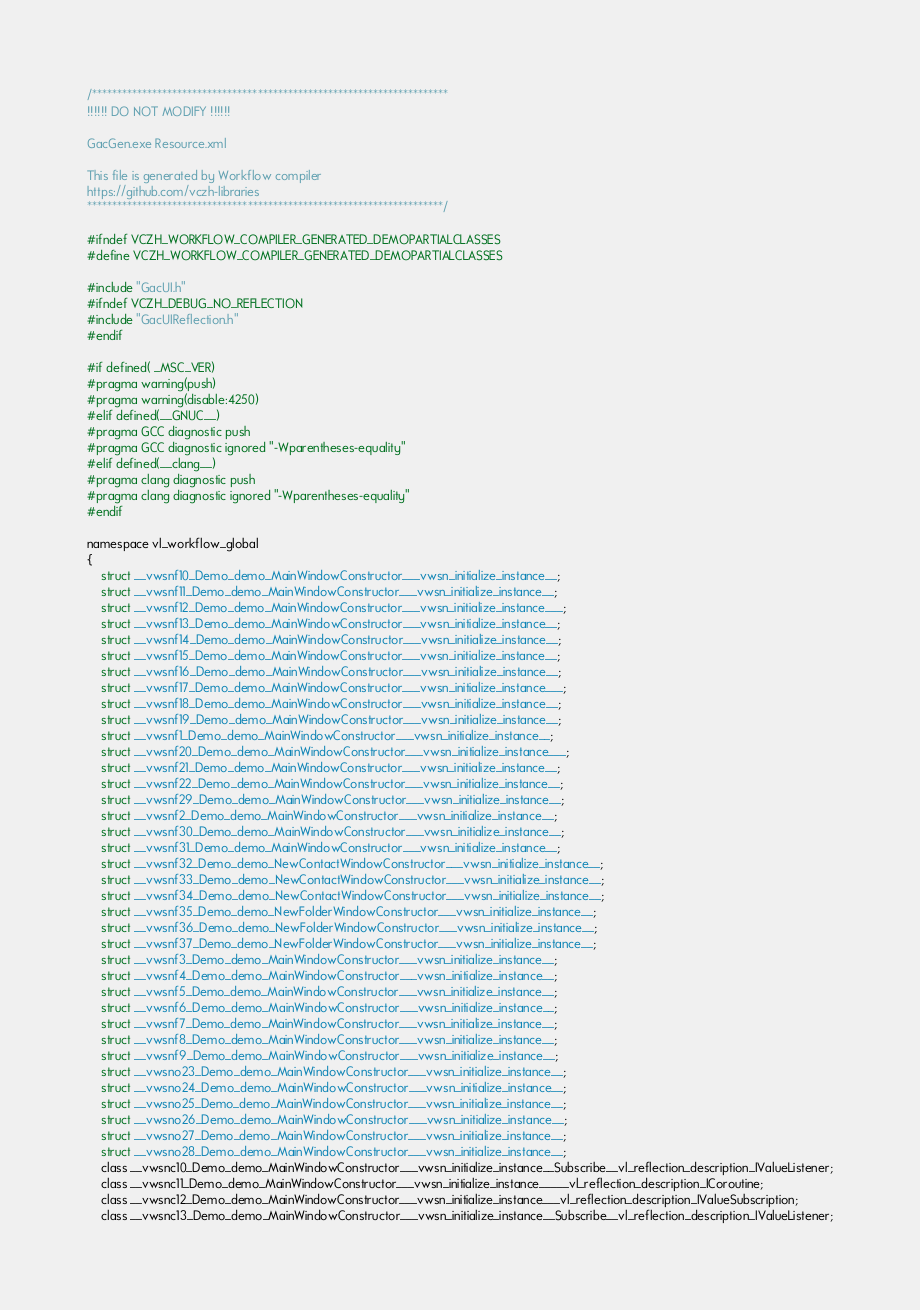Convert code to text. <code><loc_0><loc_0><loc_500><loc_500><_C_>/***********************************************************************
!!!!!! DO NOT MODIFY !!!!!!

GacGen.exe Resource.xml

This file is generated by Workflow compiler
https://github.com/vczh-libraries
***********************************************************************/

#ifndef VCZH_WORKFLOW_COMPILER_GENERATED_DEMOPARTIALCLASSES
#define VCZH_WORKFLOW_COMPILER_GENERATED_DEMOPARTIALCLASSES

#include "GacUI.h"
#ifndef VCZH_DEBUG_NO_REFLECTION
#include "GacUIReflection.h"
#endif

#if defined( _MSC_VER)
#pragma warning(push)
#pragma warning(disable:4250)
#elif defined(__GNUC__)
#pragma GCC diagnostic push
#pragma GCC diagnostic ignored "-Wparentheses-equality"
#elif defined(__clang__)
#pragma clang diagnostic push
#pragma clang diagnostic ignored "-Wparentheses-equality"
#endif

namespace vl_workflow_global
{
	struct __vwsnf10_Demo_demo_MainWindowConstructor___vwsn_initialize_instance__;
	struct __vwsnf11_Demo_demo_MainWindowConstructor___vwsn_initialize_instance__;
	struct __vwsnf12_Demo_demo_MainWindowConstructor___vwsn_initialize_instance___;
	struct __vwsnf13_Demo_demo_MainWindowConstructor___vwsn_initialize_instance__;
	struct __vwsnf14_Demo_demo_MainWindowConstructor___vwsn_initialize_instance__;
	struct __vwsnf15_Demo_demo_MainWindowConstructor___vwsn_initialize_instance__;
	struct __vwsnf16_Demo_demo_MainWindowConstructor___vwsn_initialize_instance__;
	struct __vwsnf17_Demo_demo_MainWindowConstructor___vwsn_initialize_instance___;
	struct __vwsnf18_Demo_demo_MainWindowConstructor___vwsn_initialize_instance__;
	struct __vwsnf19_Demo_demo_MainWindowConstructor___vwsn_initialize_instance__;
	struct __vwsnf1_Demo_demo_MainWindowConstructor___vwsn_initialize_instance__;
	struct __vwsnf20_Demo_demo_MainWindowConstructor___vwsn_initialize_instance___;
	struct __vwsnf21_Demo_demo_MainWindowConstructor___vwsn_initialize_instance__;
	struct __vwsnf22_Demo_demo_MainWindowConstructor___vwsn_initialize_instance__;
	struct __vwsnf29_Demo_demo_MainWindowConstructor___vwsn_initialize_instance__;
	struct __vwsnf2_Demo_demo_MainWindowConstructor___vwsn_initialize_instance__;
	struct __vwsnf30_Demo_demo_MainWindowConstructor___vwsn_initialize_instance__;
	struct __vwsnf31_Demo_demo_MainWindowConstructor___vwsn_initialize_instance__;
	struct __vwsnf32_Demo_demo_NewContactWindowConstructor___vwsn_initialize_instance__;
	struct __vwsnf33_Demo_demo_NewContactWindowConstructor___vwsn_initialize_instance__;
	struct __vwsnf34_Demo_demo_NewContactWindowConstructor___vwsn_initialize_instance__;
	struct __vwsnf35_Demo_demo_NewFolderWindowConstructor___vwsn_initialize_instance__;
	struct __vwsnf36_Demo_demo_NewFolderWindowConstructor___vwsn_initialize_instance__;
	struct __vwsnf37_Demo_demo_NewFolderWindowConstructor___vwsn_initialize_instance__;
	struct __vwsnf3_Demo_demo_MainWindowConstructor___vwsn_initialize_instance__;
	struct __vwsnf4_Demo_demo_MainWindowConstructor___vwsn_initialize_instance__;
	struct __vwsnf5_Demo_demo_MainWindowConstructor___vwsn_initialize_instance__;
	struct __vwsnf6_Demo_demo_MainWindowConstructor___vwsn_initialize_instance__;
	struct __vwsnf7_Demo_demo_MainWindowConstructor___vwsn_initialize_instance__;
	struct __vwsnf8_Demo_demo_MainWindowConstructor___vwsn_initialize_instance__;
	struct __vwsnf9_Demo_demo_MainWindowConstructor___vwsn_initialize_instance__;
	struct __vwsno23_Demo_demo_MainWindowConstructor___vwsn_initialize_instance__;
	struct __vwsno24_Demo_demo_MainWindowConstructor___vwsn_initialize_instance__;
	struct __vwsno25_Demo_demo_MainWindowConstructor___vwsn_initialize_instance__;
	struct __vwsno26_Demo_demo_MainWindowConstructor___vwsn_initialize_instance__;
	struct __vwsno27_Demo_demo_MainWindowConstructor___vwsn_initialize_instance__;
	struct __vwsno28_Demo_demo_MainWindowConstructor___vwsn_initialize_instance__;
	class __vwsnc10_Demo_demo_MainWindowConstructor___vwsn_initialize_instance__Subscribe__vl_reflection_description_IValueListener;
	class __vwsnc11_Demo_demo_MainWindowConstructor___vwsn_initialize_instance_____vl_reflection_description_ICoroutine;
	class __vwsnc12_Demo_demo_MainWindowConstructor___vwsn_initialize_instance___vl_reflection_description_IValueSubscription;
	class __vwsnc13_Demo_demo_MainWindowConstructor___vwsn_initialize_instance__Subscribe__vl_reflection_description_IValueListener;</code> 